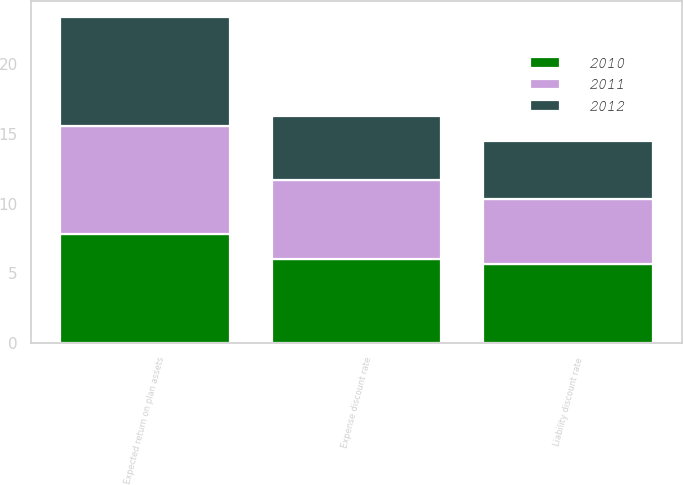Convert chart. <chart><loc_0><loc_0><loc_500><loc_500><stacked_bar_chart><ecel><fcel>Liability discount rate<fcel>Expense discount rate<fcel>Expected return on plan assets<nl><fcel>2012<fcel>4.2<fcel>4.6<fcel>7.8<nl><fcel>2011<fcel>4.6<fcel>5.7<fcel>7.8<nl><fcel>2010<fcel>5.7<fcel>6<fcel>7.8<nl></chart> 